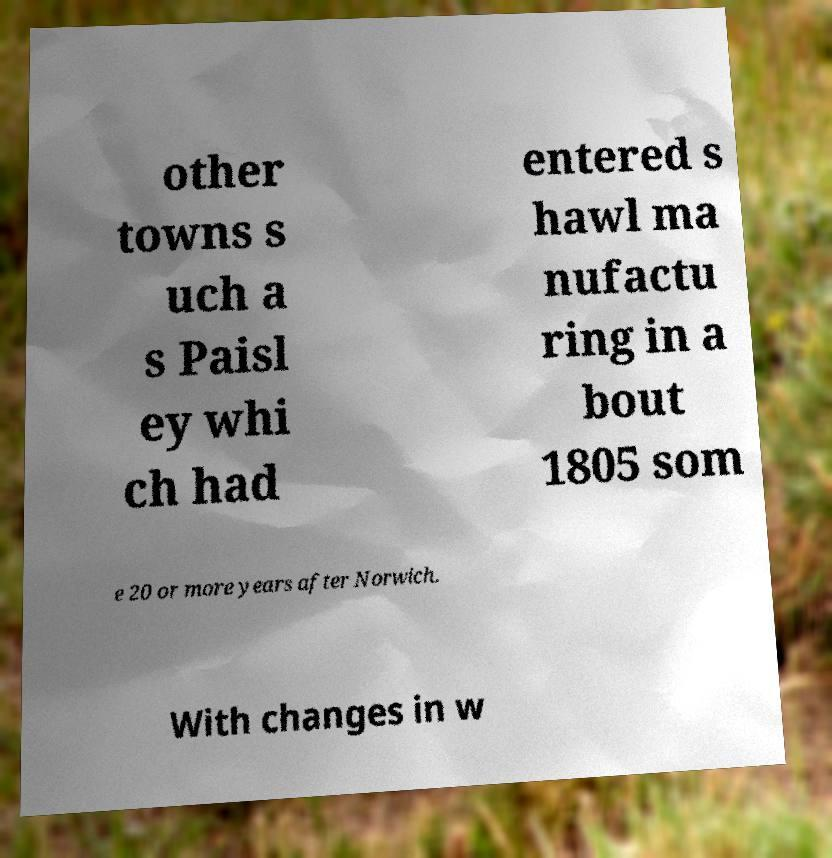Can you accurately transcribe the text from the provided image for me? other towns s uch a s Paisl ey whi ch had entered s hawl ma nufactu ring in a bout 1805 som e 20 or more years after Norwich. With changes in w 